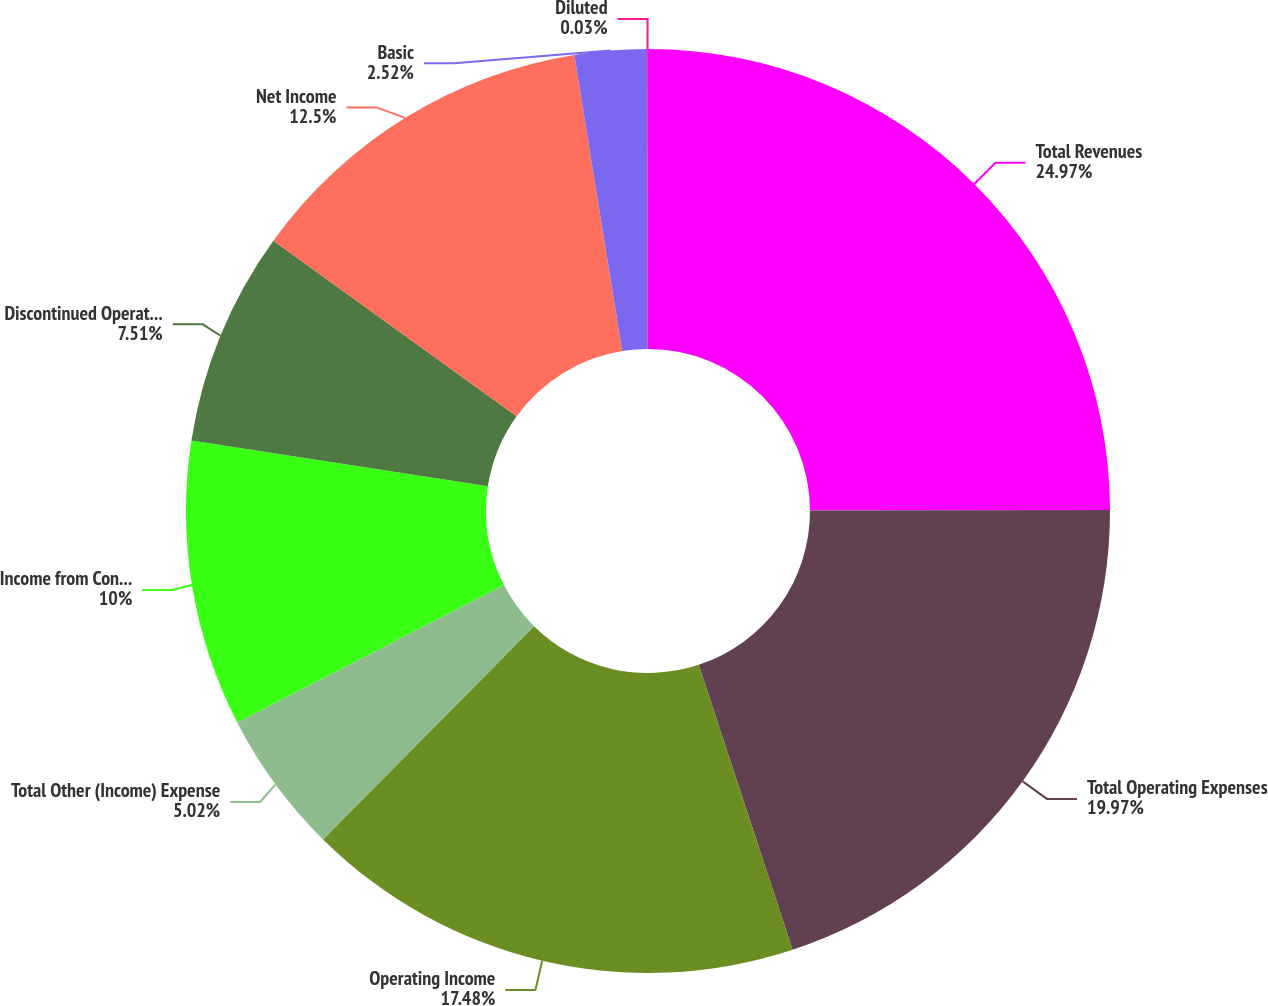Convert chart. <chart><loc_0><loc_0><loc_500><loc_500><pie_chart><fcel>Total Revenues<fcel>Total Operating Expenses<fcel>Operating Income<fcel>Total Other (Income) Expense<fcel>Income from Continuing<fcel>Discontinued Operations Net of<fcel>Net Income<fcel>Basic<fcel>Diluted<nl><fcel>24.96%<fcel>19.97%<fcel>17.48%<fcel>5.02%<fcel>10.0%<fcel>7.51%<fcel>12.5%<fcel>2.52%<fcel>0.03%<nl></chart> 